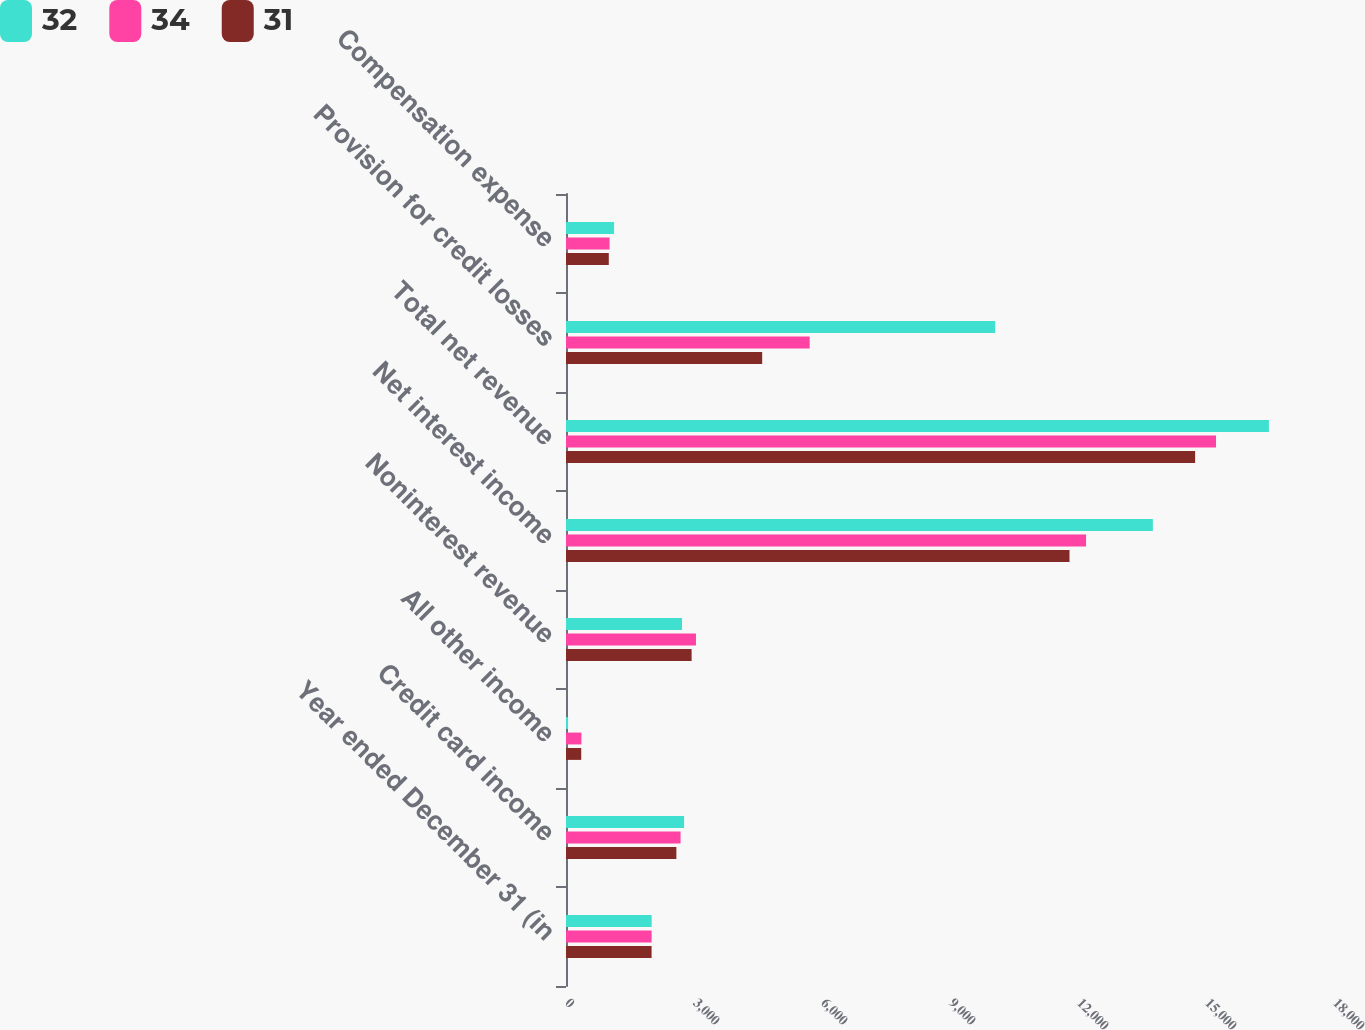Convert chart to OTSL. <chart><loc_0><loc_0><loc_500><loc_500><stacked_bar_chart><ecel><fcel>Year ended December 31 (in<fcel>Credit card income<fcel>All other income<fcel>Noninterest revenue<fcel>Net interest income<fcel>Total net revenue<fcel>Provision for credit losses<fcel>Compensation expense<nl><fcel>32<fcel>2008<fcel>2768<fcel>49<fcel>2719<fcel>13755<fcel>16474<fcel>10059<fcel>1127<nl><fcel>34<fcel>2007<fcel>2685<fcel>361<fcel>3046<fcel>12189<fcel>15235<fcel>5711<fcel>1021<nl><fcel>31<fcel>2006<fcel>2587<fcel>357<fcel>2944<fcel>11801<fcel>14745<fcel>4598<fcel>1003<nl></chart> 